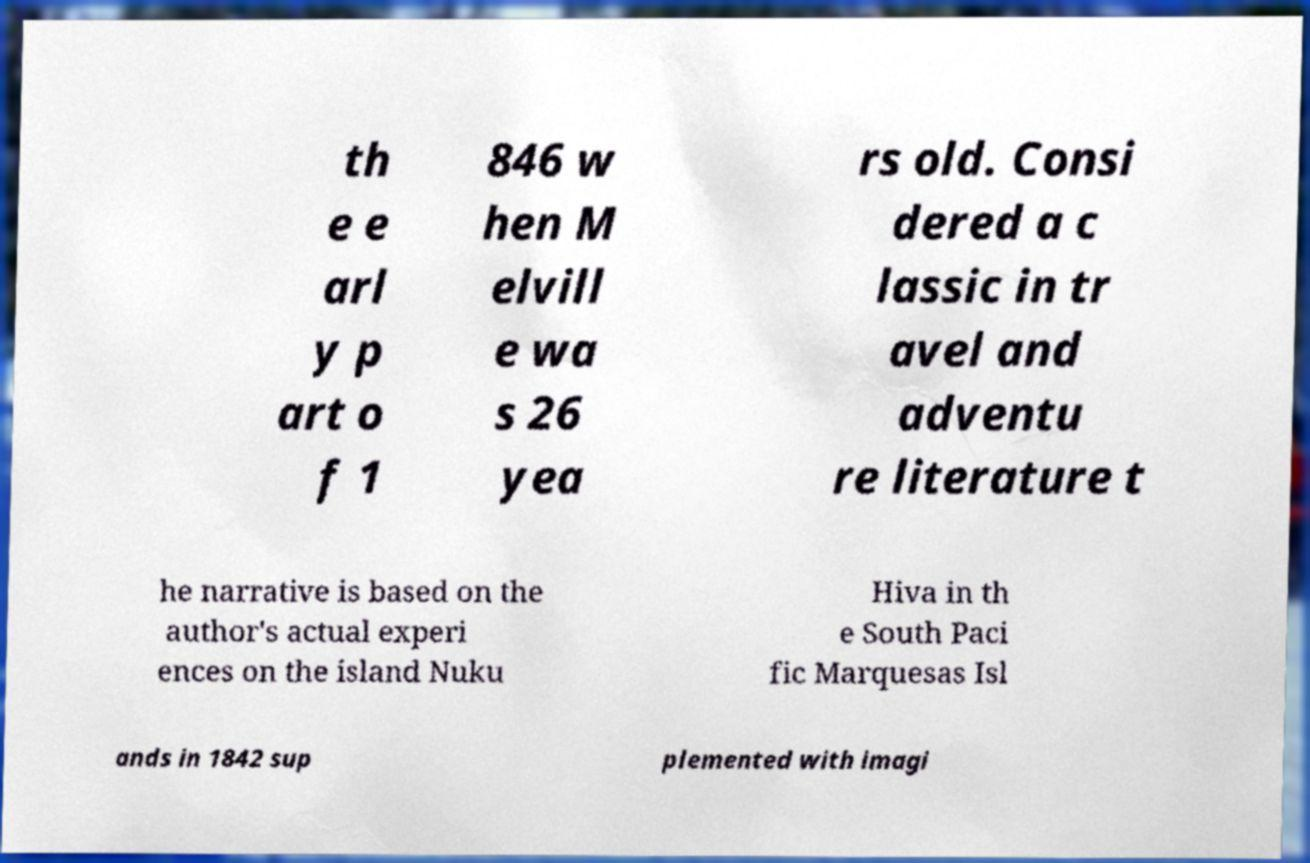For documentation purposes, I need the text within this image transcribed. Could you provide that? th e e arl y p art o f 1 846 w hen M elvill e wa s 26 yea rs old. Consi dered a c lassic in tr avel and adventu re literature t he narrative is based on the author's actual experi ences on the island Nuku Hiva in th e South Paci fic Marquesas Isl ands in 1842 sup plemented with imagi 